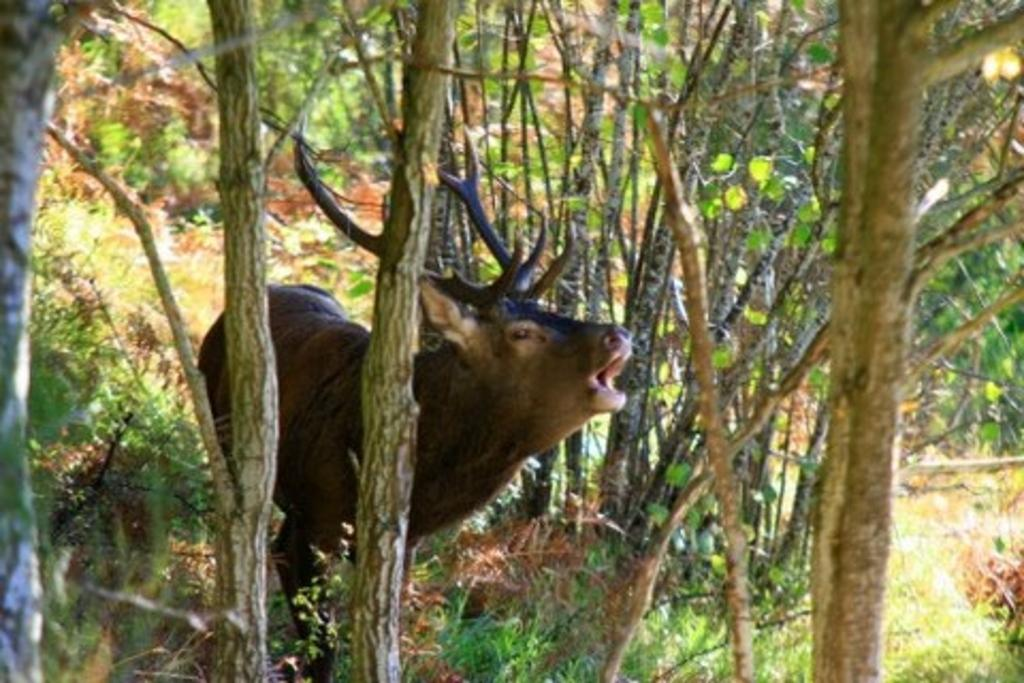What type of animal is in the picture? The type of animal cannot be determined from the provided facts. What is on the ground in the picture? There is grass on the ground in the picture. What can be seen in the background of the picture? There are trees in the background of the picture. What type of sign is visible in the picture? There is no sign present in the picture; it only features an animal, grass, and trees. 